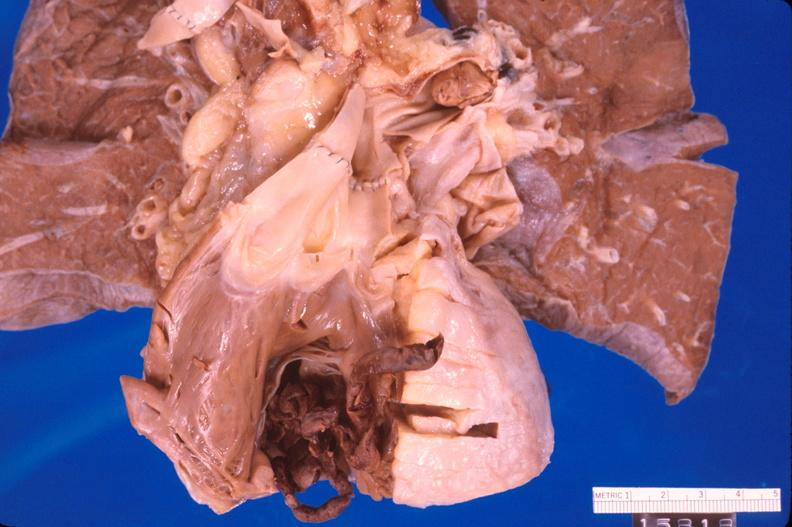what does this image show?
Answer the question using a single word or phrase. Thromboembolus from leg veins in right ventricle 